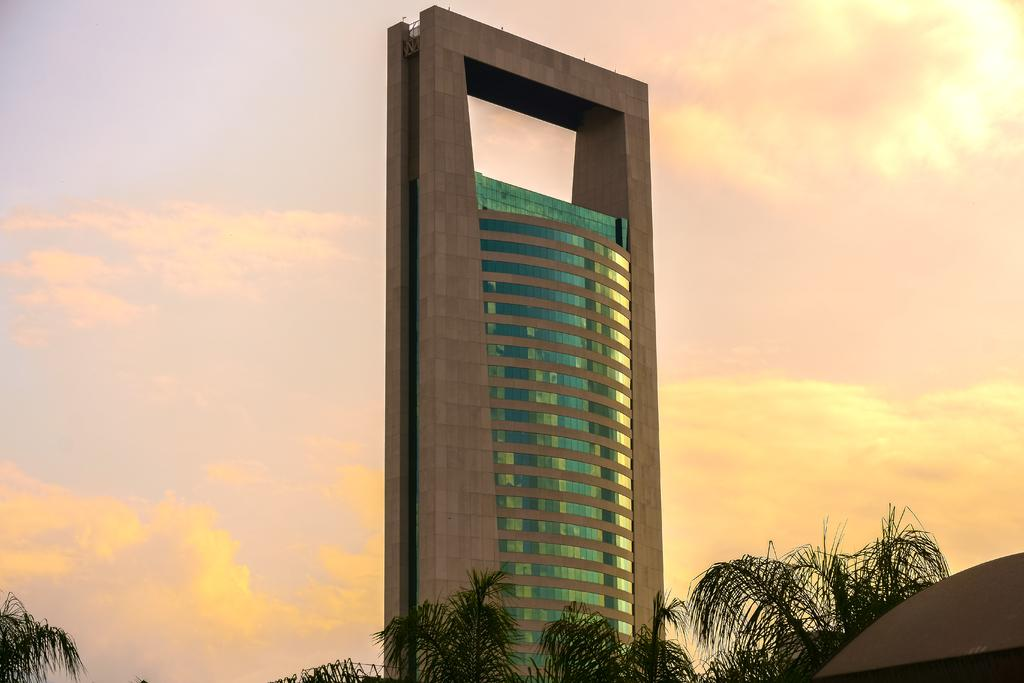What is the condition of the sky in the image? The sky is cloudy in the image. What type of structures can be seen in the image? There are buildings in the image. What feature do the buildings have? The buildings have glass windows. What is located in front of the buildings? There are trees in front of the buildings. What grade is the police officer in the image? There is no police officer present in the image. Can you tell me where the seashore is located in the image? The image does not depict a seashore; it features buildings, trees, and a cloudy sky. 